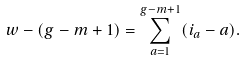<formula> <loc_0><loc_0><loc_500><loc_500>w - ( g - m + 1 ) & = \sum _ { a = 1 } ^ { g - m + 1 } ( i _ { a } - a ) .</formula> 